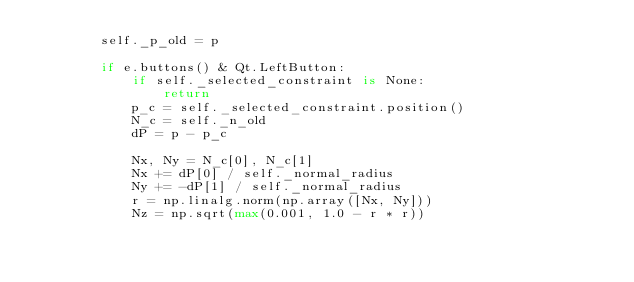<code> <loc_0><loc_0><loc_500><loc_500><_Python_>        self._p_old = p

        if e.buttons() & Qt.LeftButton:
            if self._selected_constraint is None:
                return
            p_c = self._selected_constraint.position()
            N_c = self._n_old
            dP = p - p_c

            Nx, Ny = N_c[0], N_c[1]
            Nx += dP[0] / self._normal_radius
            Ny += -dP[1] / self._normal_radius
            r = np.linalg.norm(np.array([Nx, Ny]))
            Nz = np.sqrt(max(0.001, 1.0 - r * r))</code> 